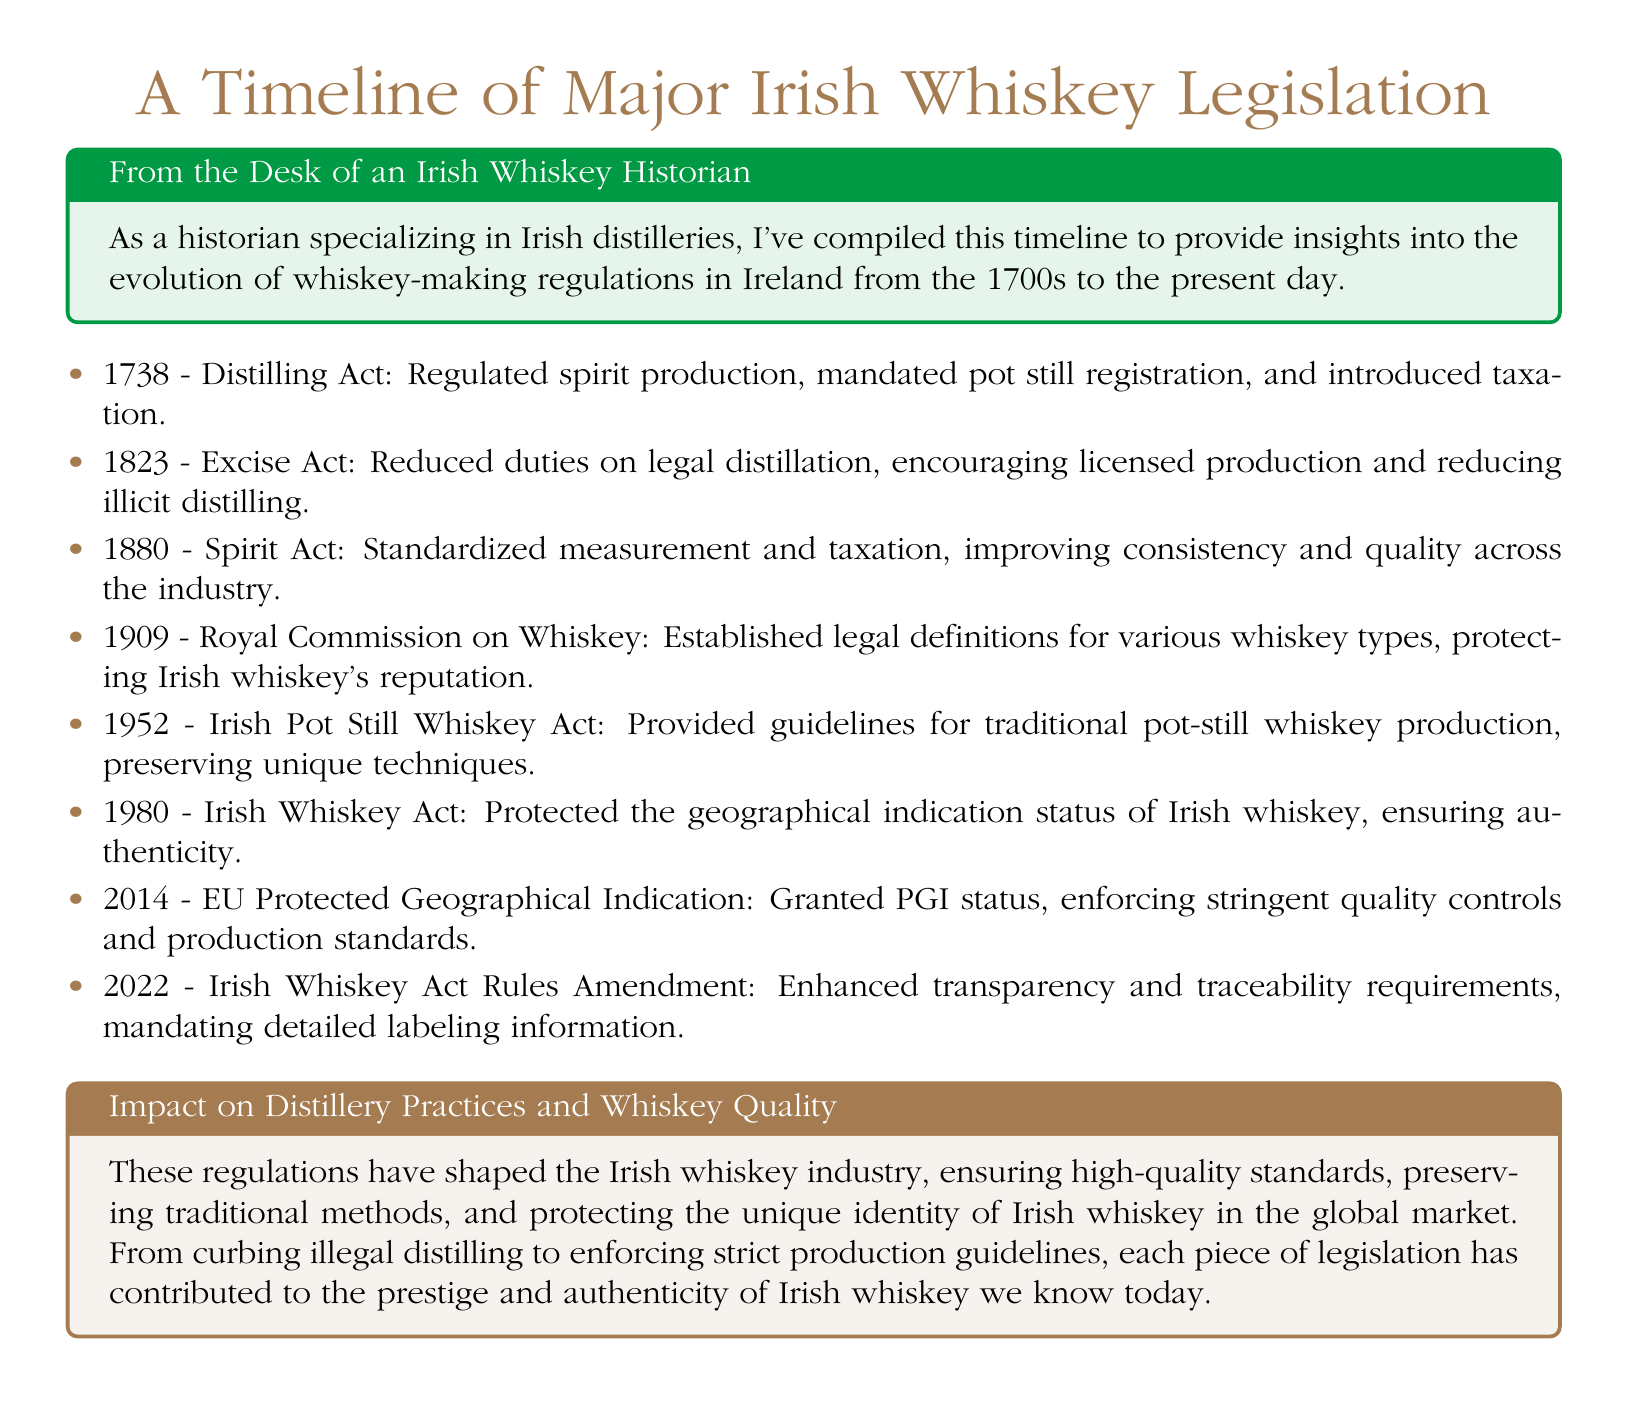What year was the Distilling Act enacted? The Distilling Act was enacted in 1738, which is specified in the timeline.
Answer: 1738 What did the 1823 Excise Act target? The 1823 Excise Act targeted duties on legal distillation, meant to encourage licensed production.
Answer: Licensed production What impact did the 1909 Royal Commission on Whiskey have? The 1909 Royal Commission on Whiskey established legal definitions for whiskey types, protecting the industry's reputation.
Answer: Legal definitions What was introduced in the 1952 Irish Pot Still Whiskey Act? The 1952 Act provided guidelines for traditional pot-still whiskey production to preserve techniques.
Answer: Guidelines for traditional production How many pieces of legislation are mentioned in the document? There are eight pieces of legislation mentioned in the timeline, each with specific details.
Answer: Eight What did the 2014 EU Protected Geographical Indication status enforce? The 2014 status enforced stringent quality controls and production standards for Irish whiskey.
Answer: Quality controls What is the significance of the term 'traceability' in the 2022 rules amendment? The term 'traceability' in the 2022 amendment refers to enhanced requirements for detailed labeling information.
Answer: Detailed labeling How did legislation affect the Irish whiskey industry's authenticity? Regulations have shaped the industry by ensuring high-quality standards and protecting the unique identity of whiskey.
Answer: High-quality standards Which act reduced illicit distilling? The 1823 Excise Act is noted for having reduced illicit distilling through its provisions.
Answer: 1823 Excise Act 